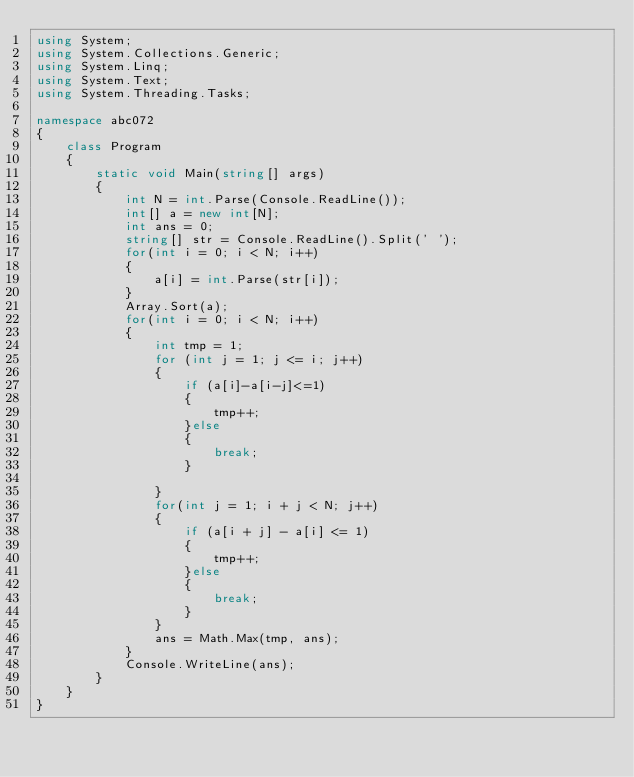Convert code to text. <code><loc_0><loc_0><loc_500><loc_500><_C#_>using System;
using System.Collections.Generic;
using System.Linq;
using System.Text;
using System.Threading.Tasks;

namespace abc072
{
    class Program
    {
        static void Main(string[] args)
        {
            int N = int.Parse(Console.ReadLine());
            int[] a = new int[N];
            int ans = 0;
            string[] str = Console.ReadLine().Split(' ');
            for(int i = 0; i < N; i++)
            {
                a[i] = int.Parse(str[i]);
            }
            Array.Sort(a);
            for(int i = 0; i < N; i++)
            {
                int tmp = 1;
                for (int j = 1; j <= i; j++)
                {
                    if (a[i]-a[i-j]<=1)
                    {
                        tmp++;
                    }else
                    {
                        break;
                    }
                    
                }
                for(int j = 1; i + j < N; j++)
                {
                    if (a[i + j] - a[i] <= 1)
                    {
                        tmp++;
                    }else
                    {
                        break;
                    }
                }
                ans = Math.Max(tmp, ans);
            }
            Console.WriteLine(ans);
        }
    }
}
</code> 